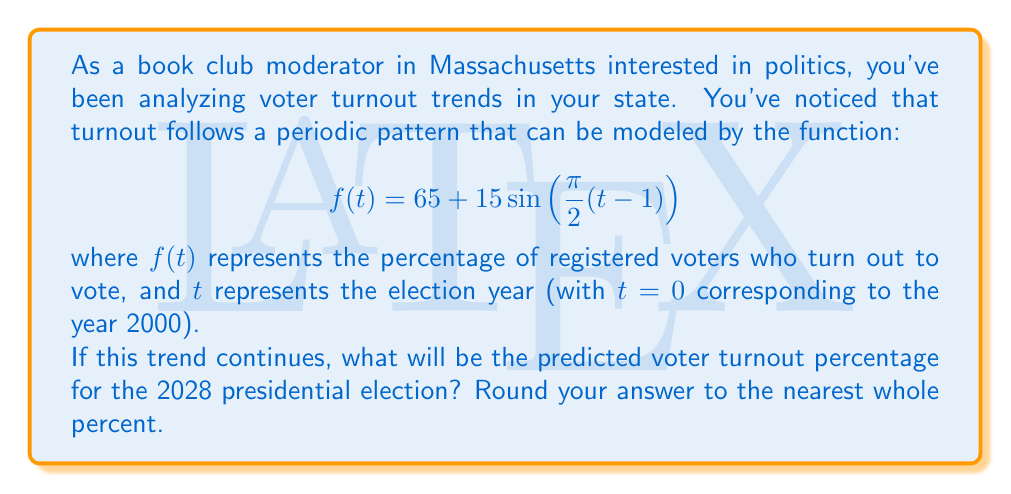Teach me how to tackle this problem. To solve this problem, we need to follow these steps:

1. Identify the year we're interested in (2028) and determine its corresponding $t$ value.
2. Substitute this $t$ value into the given function.
3. Calculate the result and round to the nearest whole percent.

Step 1: Determining $t$ for 2028
- The year 2000 corresponds to $t=0$
- 2028 is 28 years after 2000
- So, for 2028, $t = 28$

Step 2: Substituting into the function
$$ f(28) = 65 + 15\sin(\frac{\pi}{2}(28-1)) $$

Step 3: Calculating the result
$$ f(28) = 65 + 15\sin(\frac{\pi}{2}(27)) $$
$$ = 65 + 15\sin(\frac{27\pi}{2}) $$

Now, $\frac{27\pi}{2} = \frac{13\pi}{2} + 7\pi = \frac{13\pi}{2} + \pi = \frac{15\pi}{2}$

$\sin(\frac{15\pi}{2}) = \sin(\frac{\pi}{2}) = 1$

Therefore,
$$ f(28) = 65 + 15(1) = 80 $$

Rounding to the nearest whole percent: 80%
Answer: 80% 